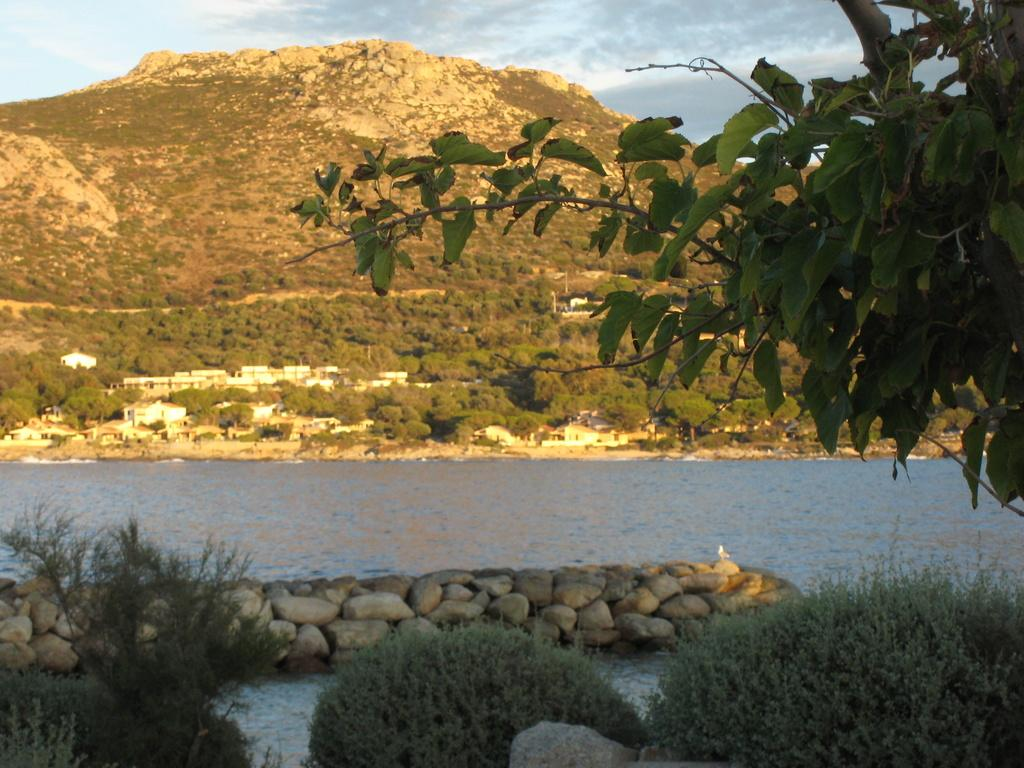What is the primary element in the image? There is water in the image. What other objects or features can be seen in the image? There are stones, plants, trees, houses, and a mountain visible in the image. What is the natural environment like in the image? The image features plants, trees, and a mountain, suggesting a natural setting. What is visible in the background of the image? There are houses, a mountain, and the sky visible in the background of the image. What type of marble is being used to construct the houses in the image? There is no mention of marble being used to construct the houses in the image. The houses are visible in the background, but their construction materials are not specified. 